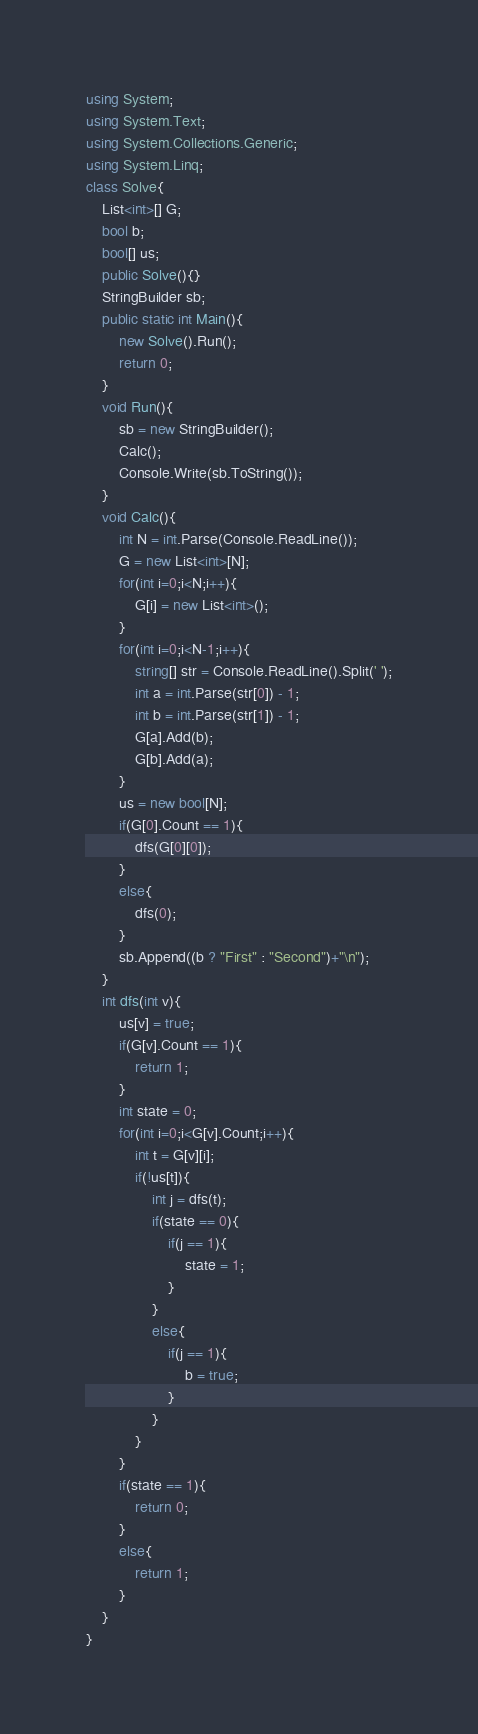Convert code to text. <code><loc_0><loc_0><loc_500><loc_500><_C#_>using System;
using System.Text;
using System.Collections.Generic;
using System.Linq;
class Solve{
    List<int>[] G;
    bool b;
    bool[] us;
    public Solve(){}
    StringBuilder sb;
    public static int Main(){
        new Solve().Run();
        return 0;
    }
    void Run(){
        sb = new StringBuilder();
        Calc();
        Console.Write(sb.ToString());
    }
    void Calc(){
        int N = int.Parse(Console.ReadLine());
        G = new List<int>[N];
        for(int i=0;i<N;i++){
            G[i] = new List<int>();
        }
        for(int i=0;i<N-1;i++){
            string[] str = Console.ReadLine().Split(' ');
            int a = int.Parse(str[0]) - 1;
            int b = int.Parse(str[1]) - 1;
            G[a].Add(b);
            G[b].Add(a);
        }
        us = new bool[N];
        if(G[0].Count == 1){
            dfs(G[0][0]);
        }
        else{
            dfs(0);
        }
        sb.Append((b ? "First" : "Second")+"\n");
    }
    int dfs(int v){
        us[v] = true;
        if(G[v].Count == 1){
            return 1;
        }
        int state = 0;
        for(int i=0;i<G[v].Count;i++){
            int t = G[v][i];
            if(!us[t]){
                int j = dfs(t);
                if(state == 0){
                    if(j == 1){
                        state = 1;
                    }
                }
                else{
                    if(j == 1){
                        b = true;
                    }
                }
            }
        }
        if(state == 1){
            return 0;
        }
        else{
            return 1;
        }
    }
}</code> 